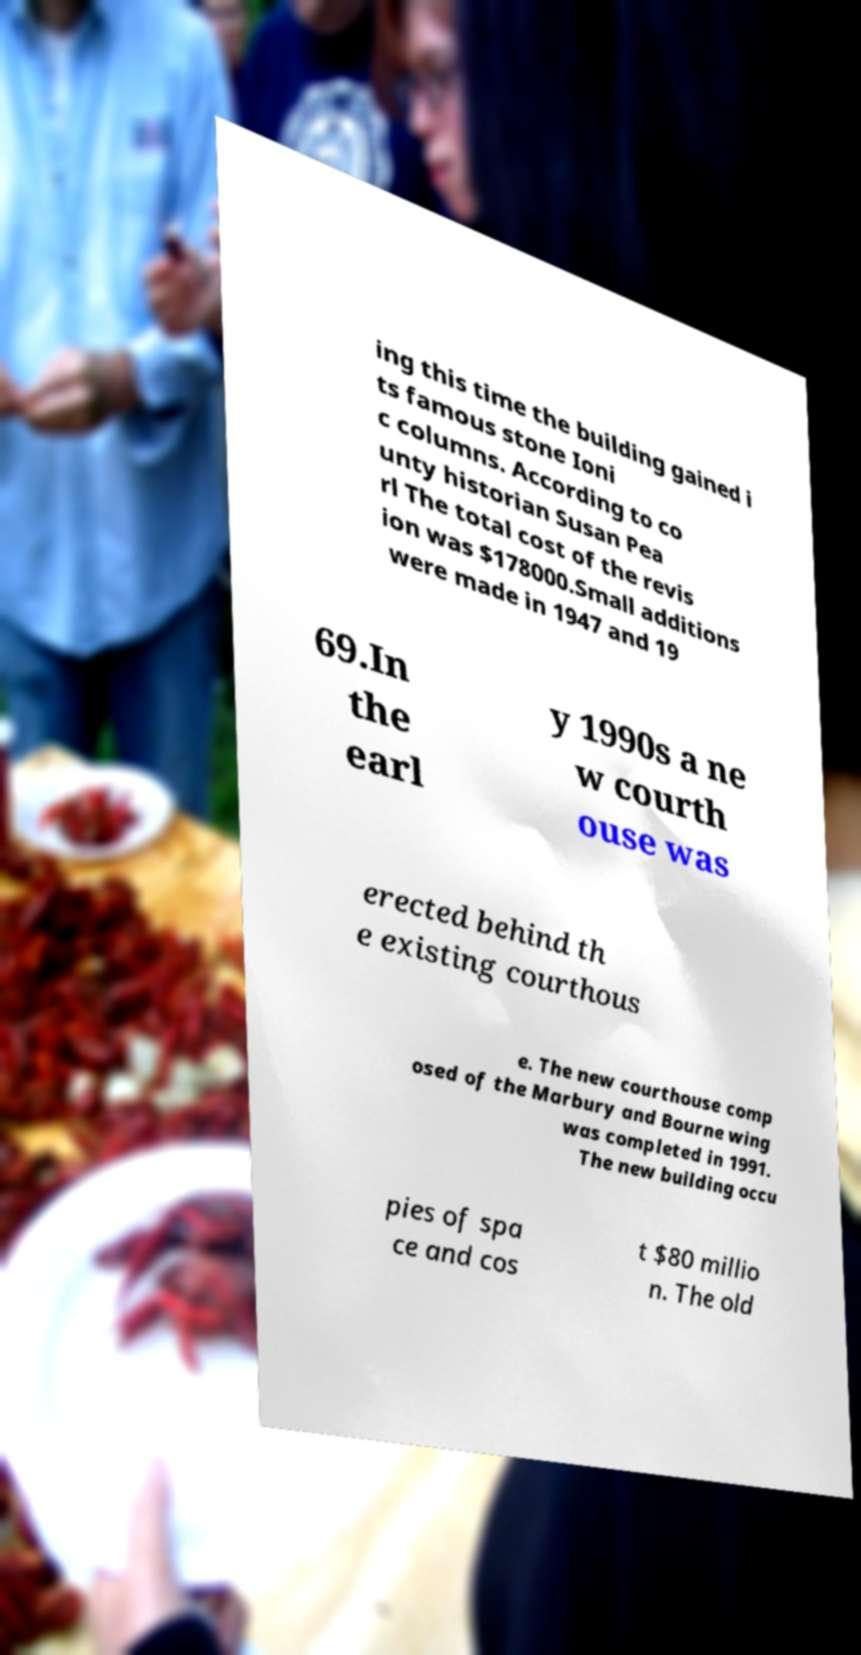Could you assist in decoding the text presented in this image and type it out clearly? ing this time the building gained i ts famous stone Ioni c columns. According to co unty historian Susan Pea rl The total cost of the revis ion was $178000.Small additions were made in 1947 and 19 69.In the earl y 1990s a ne w courth ouse was erected behind th e existing courthous e. The new courthouse comp osed of the Marbury and Bourne wing was completed in 1991. The new building occu pies of spa ce and cos t $80 millio n. The old 